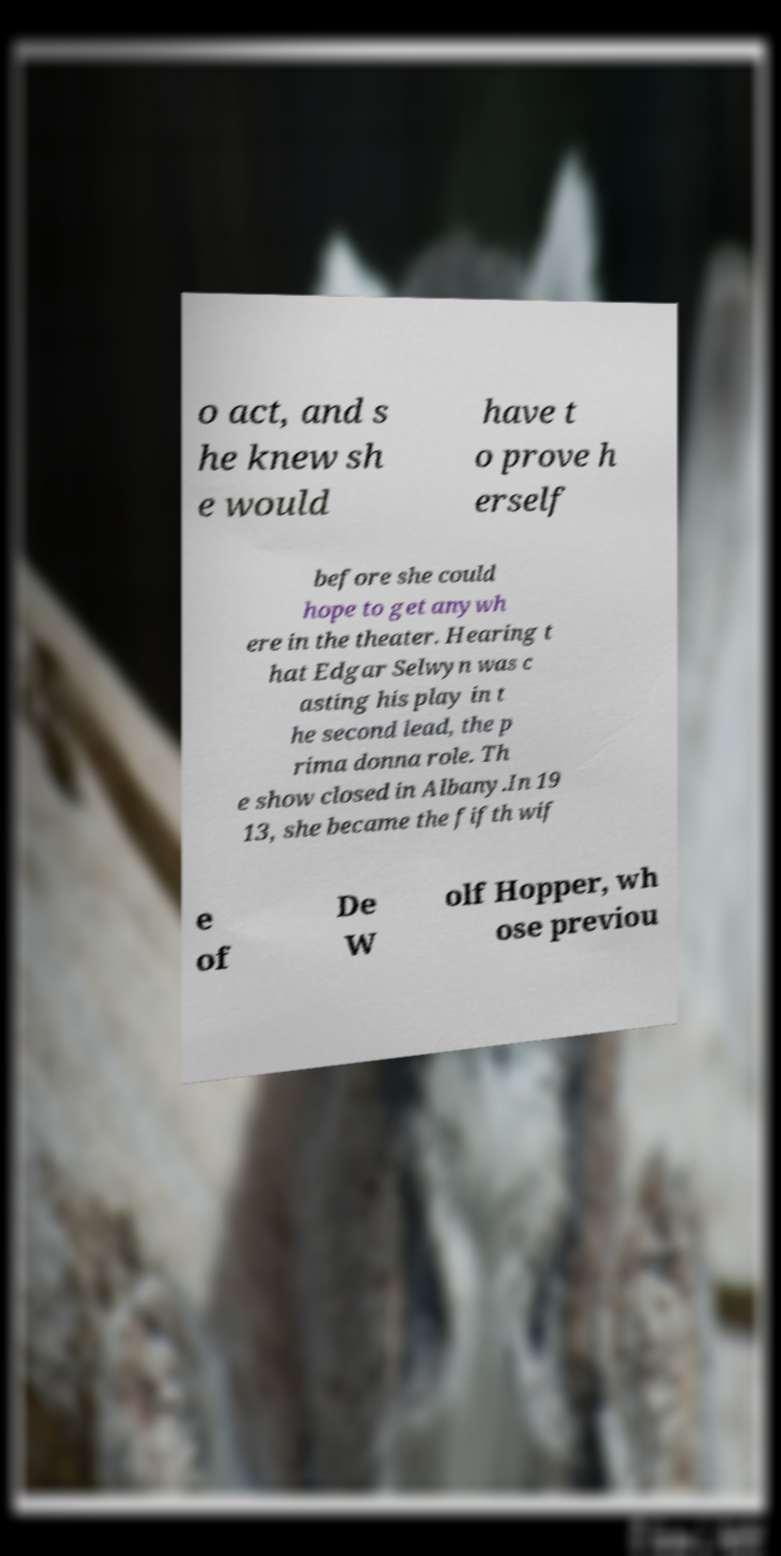Please identify and transcribe the text found in this image. o act, and s he knew sh e would have t o prove h erself before she could hope to get anywh ere in the theater. Hearing t hat Edgar Selwyn was c asting his play in t he second lead, the p rima donna role. Th e show closed in Albany.In 19 13, she became the fifth wif e of De W olf Hopper, wh ose previou 